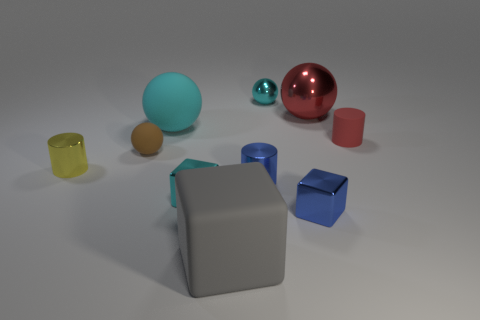What is the material of the large sphere that is behind the big ball that is left of the rubber thing that is in front of the small rubber sphere?
Provide a succinct answer. Metal. Is there any other thing that has the same material as the yellow object?
Keep it short and to the point. Yes. Is the color of the metal ball on the left side of the red metallic ball the same as the big rubber sphere?
Your answer should be very brief. Yes. What number of blue things are either metal cylinders or cubes?
Offer a terse response. 2. How many other things are the same shape as the tiny yellow metal thing?
Offer a terse response. 2. Does the big red sphere have the same material as the tiny blue cylinder?
Offer a terse response. Yes. There is a cyan object that is both to the left of the large gray rubber object and behind the tiny red matte thing; what is its material?
Provide a succinct answer. Rubber. There is a rubber thing that is to the right of the large red shiny ball; what color is it?
Provide a succinct answer. Red. Are there more small rubber cylinders that are to the left of the big cyan thing than large red objects?
Provide a short and direct response. No. How many other things are the same size as the blue block?
Offer a very short reply. 6. 